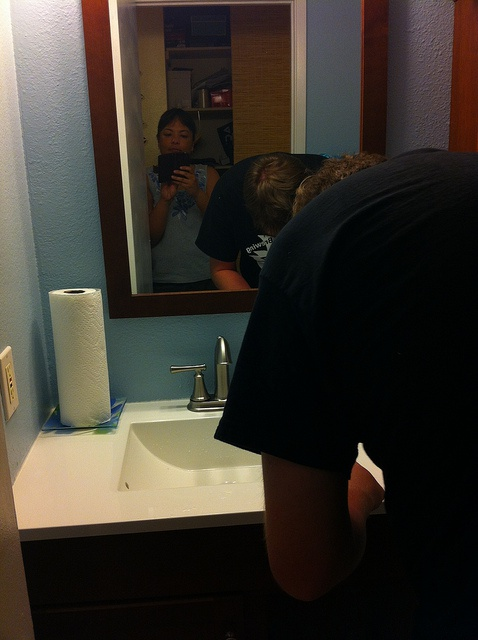Describe the objects in this image and their specific colors. I can see people in beige, black, maroon, tan, and gray tones, sink in beige, tan, and black tones, people in beige, black, maroon, and gray tones, and cell phone in black and beige tones in this image. 